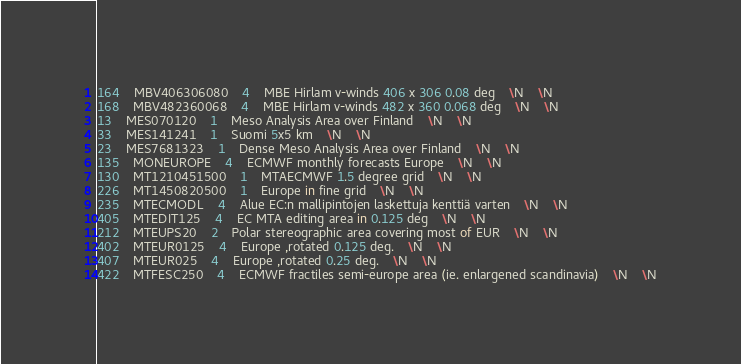<code> <loc_0><loc_0><loc_500><loc_500><_SQL_>164	MBV406306080	4	MBE Hirlam v-winds 406 x 306 0.08 deg	\N	\N
168	MBV482360068	4	MBE Hirlam v-winds 482 x 360 0.068 deg	\N	\N
13	MES070120	1	Meso Analysis Area over Finland	\N	\N
33	MES141241	1	Suomi 5x5 km	\N	\N
23	MES7681323	1	Dense Meso Analysis Area over Finland	\N	\N
135	MONEUROPE	4	ECMWF monthly forecasts Europe	\N	\N
130	MT1210451500	1	MTAECMWF 1.5 degree grid	\N	\N
226	MT1450820500	1	Europe in fine grid	\N	\N
235	MTECMODL	4	Alue EC:n mallipintojen laskettuja kenttiä varten	\N	\N
405	MTEDIT125	4	EC MTA editing area in 0.125 deg	\N	\N
212	MTEUPS20	2	Polar stereographic area covering most of EUR	\N	\N
402	MTEUR0125	4	Europe ,rotated 0.125 deg.	\N	\N
407	MTEUR025	4	Europe ,rotated 0.25 deg.	\N	\N
422	MTFESC250	4	ECMWF fractiles semi-europe area (ie. enlargened scandinavia)	\N	\N</code> 